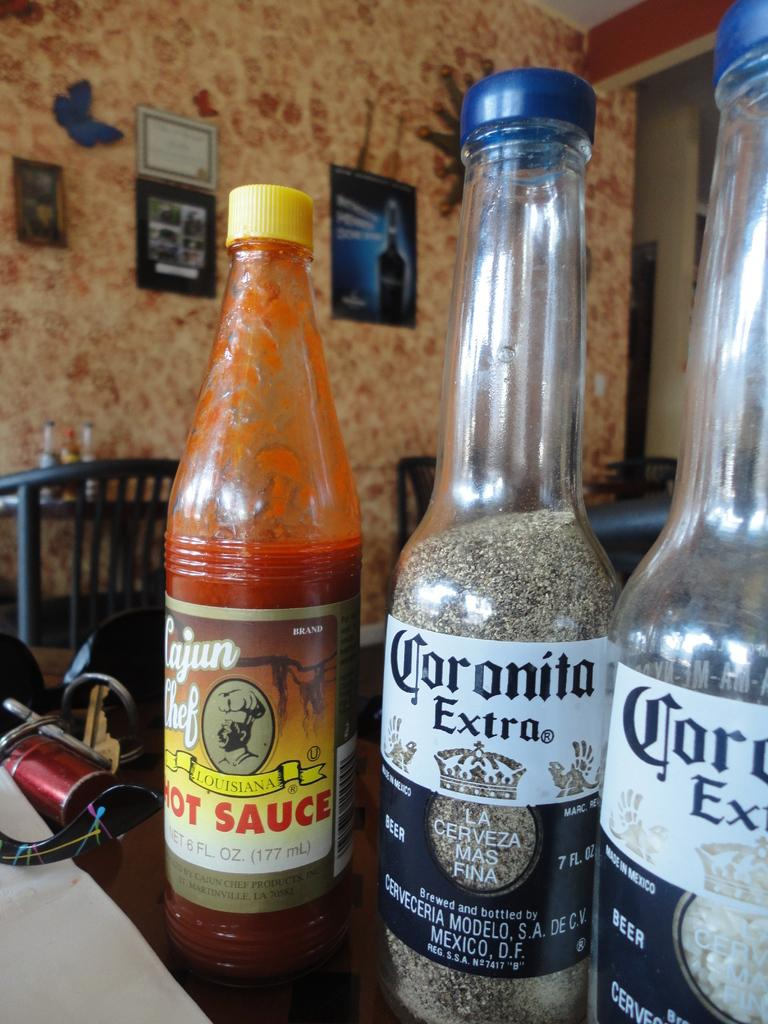How many bottles are on the table in the image? There are three bottles on the table in the image. What type of beverage do two of the bottles contain? Two of the bottles contain Corona Extra. What is the third bottle on the table? The third bottle is hot sauce. What can be seen behind the table in the image? The background is a wall. What color is the wall in the image? The wall is orange in color. Can you hear the kitten talking to the drawer in the image? There is no kitten or drawer present in the image, so it is not possible to hear any conversation between them. 